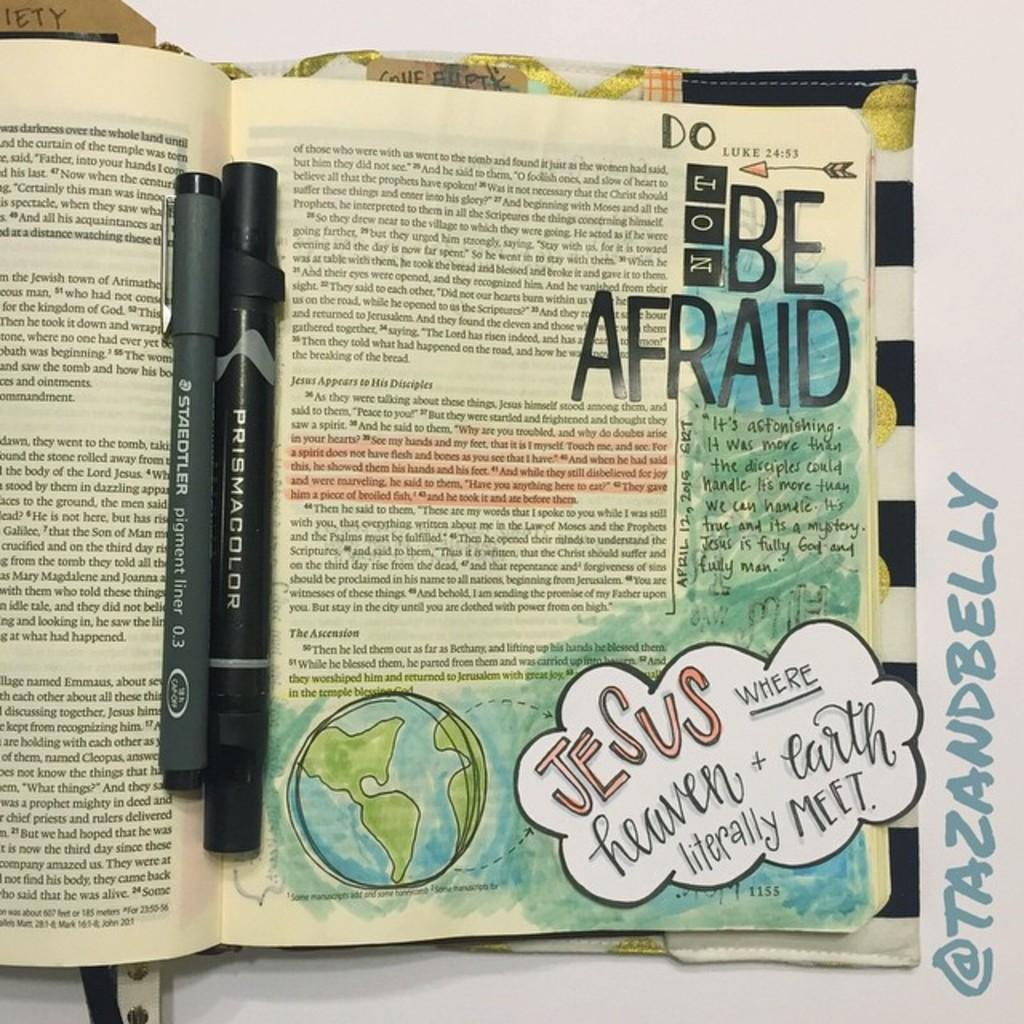<image>
Create a compact narrative representing the image presented. A book page covered in scribbles and stickers with the phrase "Do not be afraid." 